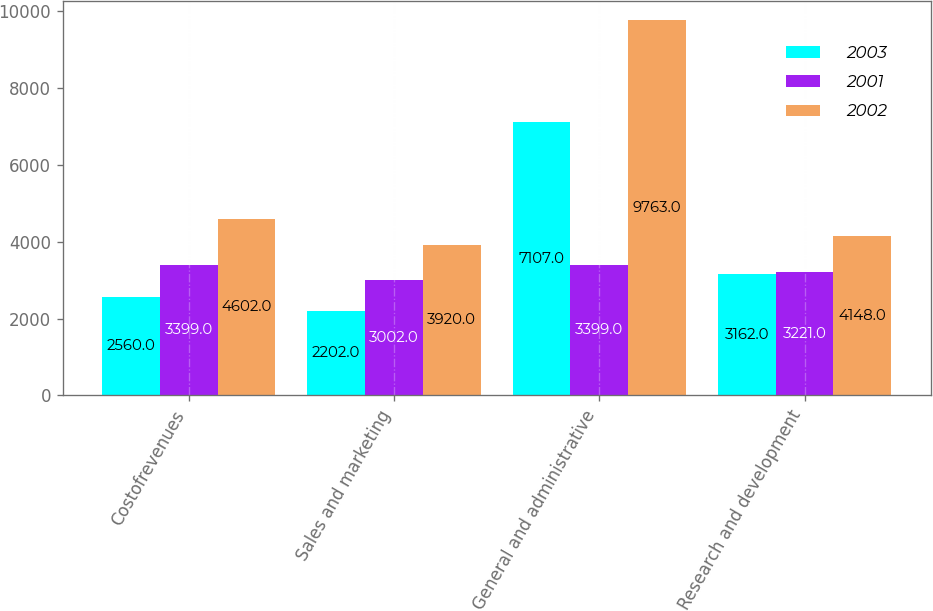Convert chart to OTSL. <chart><loc_0><loc_0><loc_500><loc_500><stacked_bar_chart><ecel><fcel>Costofrevenues<fcel>Sales and marketing<fcel>General and administrative<fcel>Research and development<nl><fcel>2003<fcel>2560<fcel>2202<fcel>7107<fcel>3162<nl><fcel>2001<fcel>3399<fcel>3002<fcel>3399<fcel>3221<nl><fcel>2002<fcel>4602<fcel>3920<fcel>9763<fcel>4148<nl></chart> 